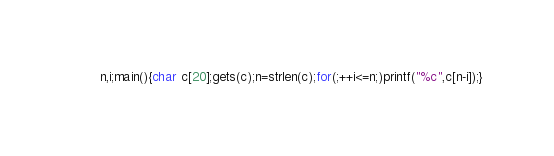<code> <loc_0><loc_0><loc_500><loc_500><_C_>n,i;main(){char c[20];gets(c);n=strlen(c);for(;++i<=n;)printf("%c",c[n-i]);}</code> 